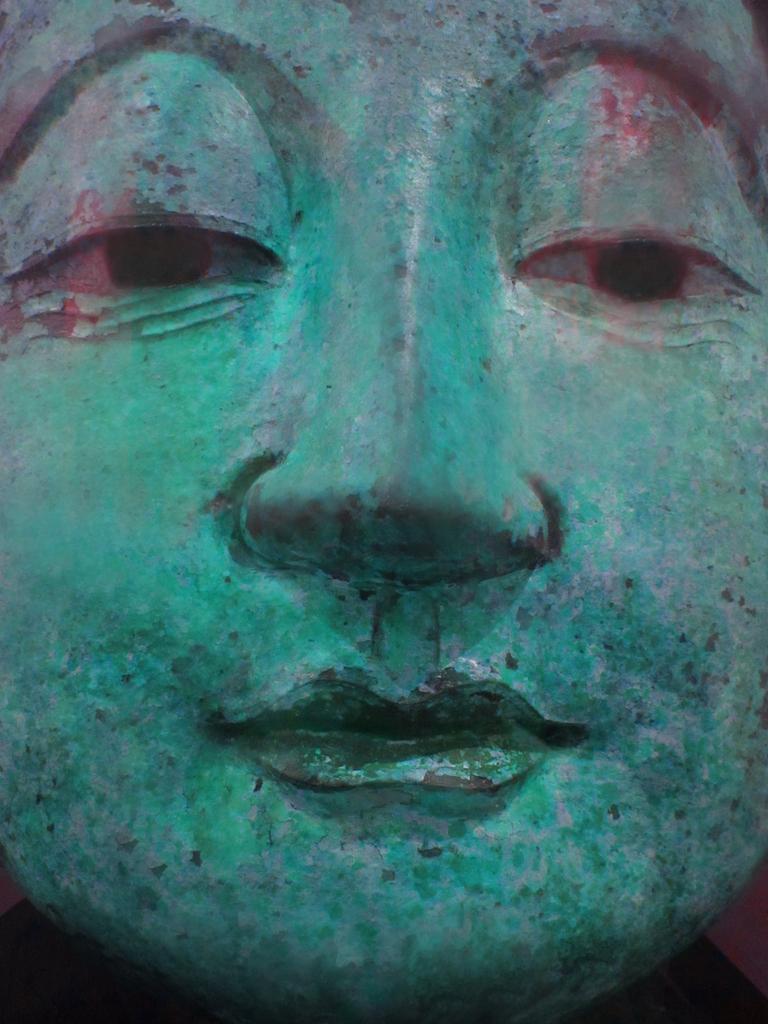Describe this image in one or two sentences. This image consists of a sculpture. It looks like a real image. It is in green color. 